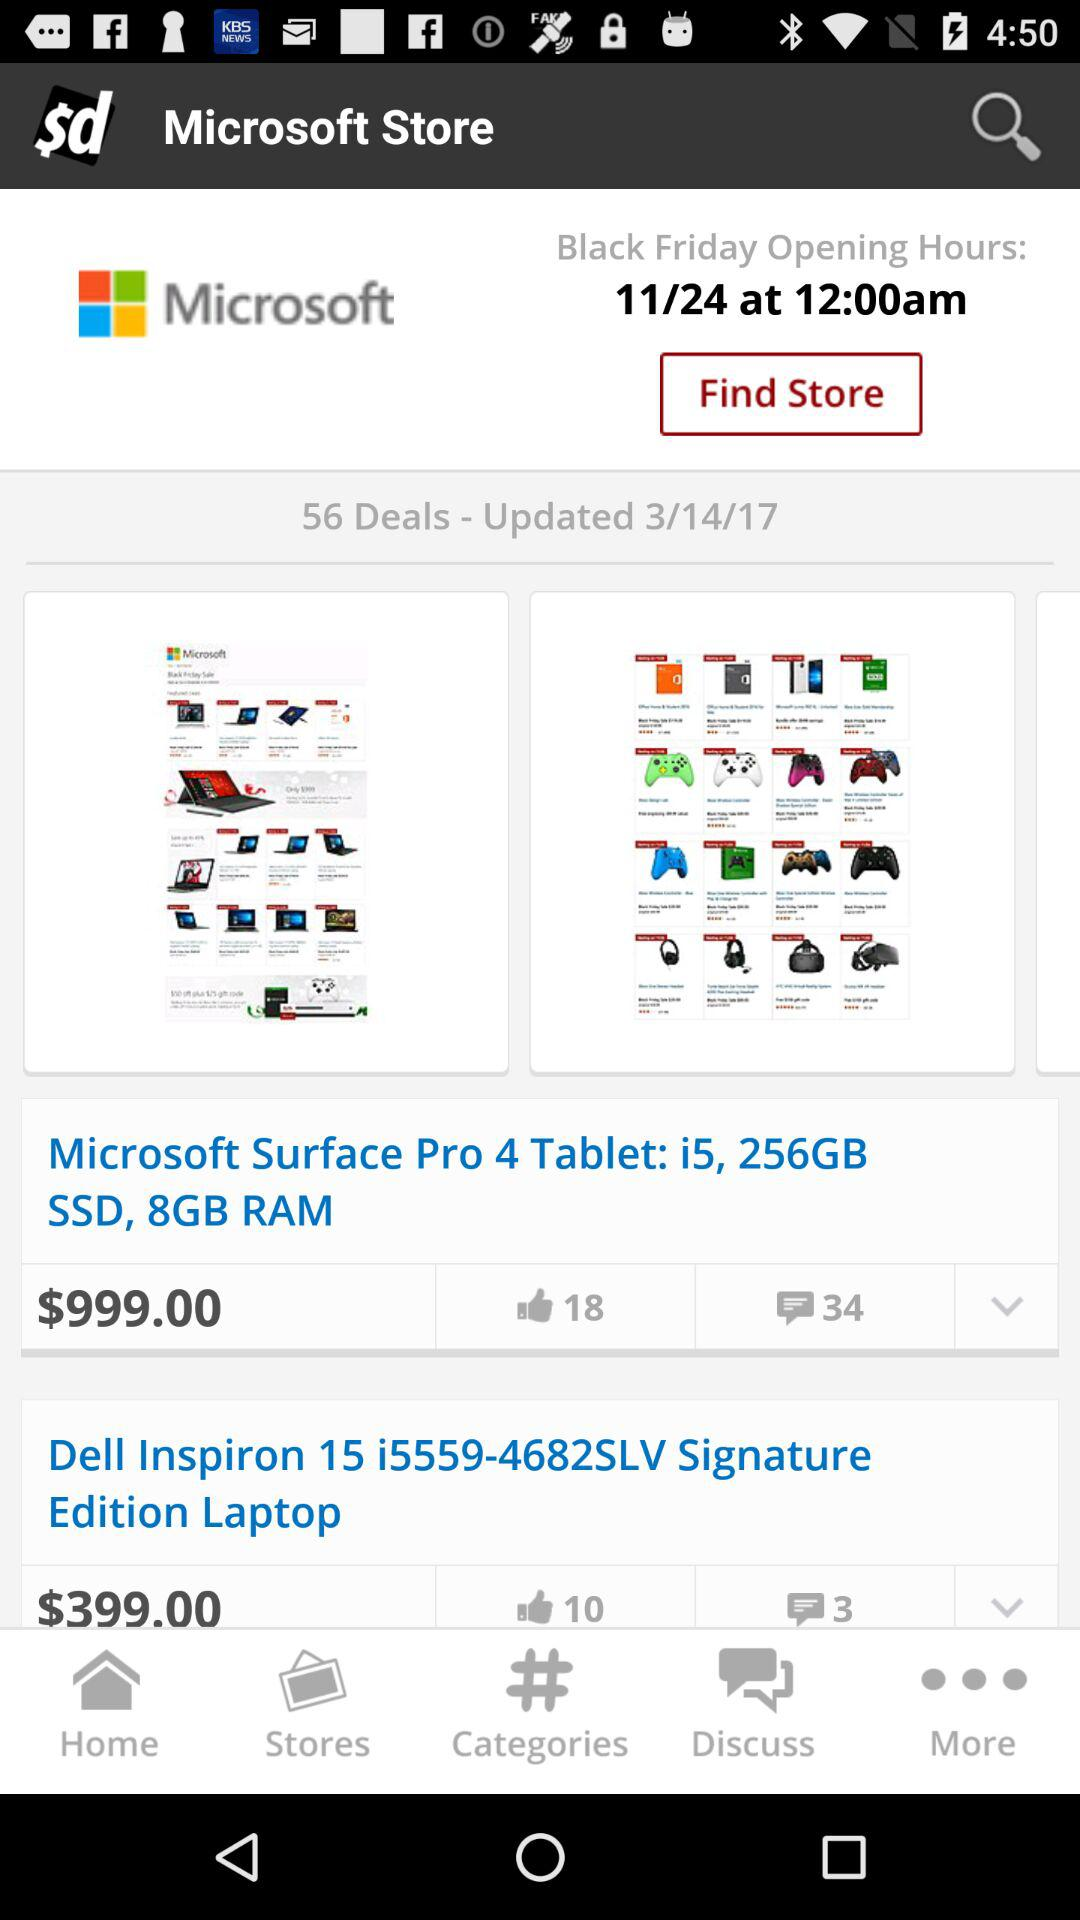How many comments are there? There are 34 and 3 comments. 